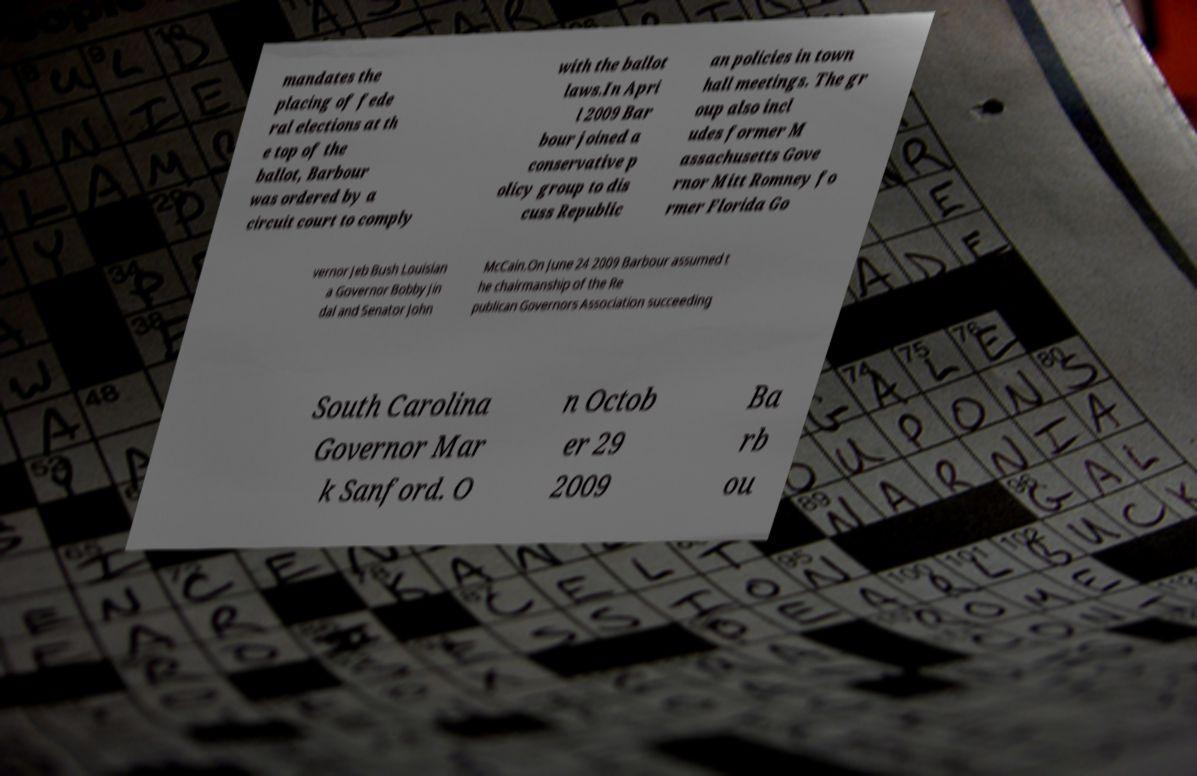Please read and relay the text visible in this image. What does it say? mandates the placing of fede ral elections at th e top of the ballot, Barbour was ordered by a circuit court to comply with the ballot laws.In Apri l 2009 Bar bour joined a conservative p olicy group to dis cuss Republic an policies in town hall meetings. The gr oup also incl udes former M assachusetts Gove rnor Mitt Romney fo rmer Florida Go vernor Jeb Bush Louisian a Governor Bobby Jin dal and Senator John McCain.On June 24 2009 Barbour assumed t he chairmanship of the Re publican Governors Association succeeding South Carolina Governor Mar k Sanford. O n Octob er 29 2009 Ba rb ou 